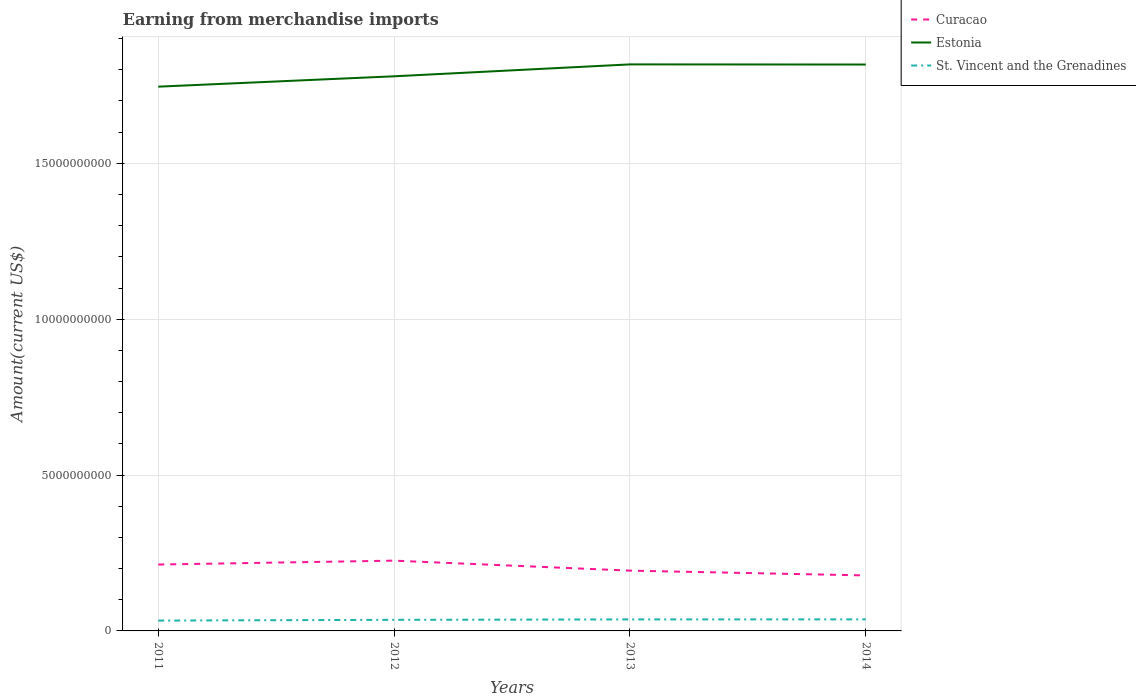Is the number of lines equal to the number of legend labels?
Your answer should be very brief. Yes. Across all years, what is the maximum amount earned from merchandise imports in Estonia?
Keep it short and to the point. 1.75e+1. In which year was the amount earned from merchandise imports in Curacao maximum?
Provide a short and direct response. 2014. What is the total amount earned from merchandise imports in Estonia in the graph?
Make the answer very short. -3.78e+08. What is the difference between the highest and the second highest amount earned from merchandise imports in Estonia?
Provide a short and direct response. 7.15e+08. How many lines are there?
Make the answer very short. 3. What is the difference between two consecutive major ticks on the Y-axis?
Make the answer very short. 5.00e+09. Are the values on the major ticks of Y-axis written in scientific E-notation?
Your response must be concise. No. Where does the legend appear in the graph?
Provide a short and direct response. Top right. What is the title of the graph?
Ensure brevity in your answer.  Earning from merchandise imports. Does "United States" appear as one of the legend labels in the graph?
Provide a short and direct response. No. What is the label or title of the Y-axis?
Offer a terse response. Amount(current US$). What is the Amount(current US$) in Curacao in 2011?
Your answer should be very brief. 2.13e+09. What is the Amount(current US$) in Estonia in 2011?
Give a very brief answer. 1.75e+1. What is the Amount(current US$) in St. Vincent and the Grenadines in 2011?
Give a very brief answer. 3.32e+08. What is the Amount(current US$) of Curacao in 2012?
Your answer should be very brief. 2.25e+09. What is the Amount(current US$) in Estonia in 2012?
Your answer should be compact. 1.78e+1. What is the Amount(current US$) of St. Vincent and the Grenadines in 2012?
Ensure brevity in your answer.  3.56e+08. What is the Amount(current US$) of Curacao in 2013?
Provide a succinct answer. 1.93e+09. What is the Amount(current US$) of Estonia in 2013?
Keep it short and to the point. 1.82e+1. What is the Amount(current US$) in St. Vincent and the Grenadines in 2013?
Your answer should be very brief. 3.69e+08. What is the Amount(current US$) in Curacao in 2014?
Your response must be concise. 1.78e+09. What is the Amount(current US$) in Estonia in 2014?
Provide a succinct answer. 1.82e+1. What is the Amount(current US$) of St. Vincent and the Grenadines in 2014?
Provide a succinct answer. 3.71e+08. Across all years, what is the maximum Amount(current US$) of Curacao?
Your response must be concise. 2.25e+09. Across all years, what is the maximum Amount(current US$) of Estonia?
Your answer should be compact. 1.82e+1. Across all years, what is the maximum Amount(current US$) in St. Vincent and the Grenadines?
Give a very brief answer. 3.71e+08. Across all years, what is the minimum Amount(current US$) in Curacao?
Your response must be concise. 1.78e+09. Across all years, what is the minimum Amount(current US$) in Estonia?
Your response must be concise. 1.75e+1. Across all years, what is the minimum Amount(current US$) of St. Vincent and the Grenadines?
Your answer should be very brief. 3.32e+08. What is the total Amount(current US$) of Curacao in the graph?
Give a very brief answer. 8.10e+09. What is the total Amount(current US$) in Estonia in the graph?
Provide a short and direct response. 7.16e+1. What is the total Amount(current US$) in St. Vincent and the Grenadines in the graph?
Provide a short and direct response. 1.43e+09. What is the difference between the Amount(current US$) in Curacao in 2011 and that in 2012?
Offer a terse response. -1.25e+08. What is the difference between the Amount(current US$) of Estonia in 2011 and that in 2012?
Offer a very short reply. -3.32e+08. What is the difference between the Amount(current US$) in St. Vincent and the Grenadines in 2011 and that in 2012?
Your response must be concise. -2.43e+07. What is the difference between the Amount(current US$) of Curacao in 2011 and that in 2013?
Your response must be concise. 1.96e+08. What is the difference between the Amount(current US$) of Estonia in 2011 and that in 2013?
Your response must be concise. -7.15e+08. What is the difference between the Amount(current US$) in St. Vincent and the Grenadines in 2011 and that in 2013?
Your answer should be very brief. -3.75e+07. What is the difference between the Amount(current US$) in Curacao in 2011 and that in 2014?
Make the answer very short. 3.50e+08. What is the difference between the Amount(current US$) in Estonia in 2011 and that in 2014?
Ensure brevity in your answer.  -7.10e+08. What is the difference between the Amount(current US$) of St. Vincent and the Grenadines in 2011 and that in 2014?
Ensure brevity in your answer.  -3.93e+07. What is the difference between the Amount(current US$) of Curacao in 2012 and that in 2013?
Provide a succinct answer. 3.20e+08. What is the difference between the Amount(current US$) in Estonia in 2012 and that in 2013?
Provide a succinct answer. -3.82e+08. What is the difference between the Amount(current US$) of St. Vincent and the Grenadines in 2012 and that in 2013?
Your answer should be very brief. -1.32e+07. What is the difference between the Amount(current US$) in Curacao in 2012 and that in 2014?
Offer a very short reply. 4.74e+08. What is the difference between the Amount(current US$) in Estonia in 2012 and that in 2014?
Give a very brief answer. -3.78e+08. What is the difference between the Amount(current US$) of St. Vincent and the Grenadines in 2012 and that in 2014?
Your answer should be very brief. -1.50e+07. What is the difference between the Amount(current US$) in Curacao in 2013 and that in 2014?
Your response must be concise. 1.54e+08. What is the difference between the Amount(current US$) in Estonia in 2013 and that in 2014?
Give a very brief answer. 4.62e+06. What is the difference between the Amount(current US$) of St. Vincent and the Grenadines in 2013 and that in 2014?
Provide a succinct answer. -1.76e+06. What is the difference between the Amount(current US$) in Curacao in 2011 and the Amount(current US$) in Estonia in 2012?
Make the answer very short. -1.57e+1. What is the difference between the Amount(current US$) in Curacao in 2011 and the Amount(current US$) in St. Vincent and the Grenadines in 2012?
Make the answer very short. 1.77e+09. What is the difference between the Amount(current US$) of Estonia in 2011 and the Amount(current US$) of St. Vincent and the Grenadines in 2012?
Make the answer very short. 1.71e+1. What is the difference between the Amount(current US$) in Curacao in 2011 and the Amount(current US$) in Estonia in 2013?
Your answer should be compact. -1.60e+1. What is the difference between the Amount(current US$) of Curacao in 2011 and the Amount(current US$) of St. Vincent and the Grenadines in 2013?
Offer a very short reply. 1.76e+09. What is the difference between the Amount(current US$) in Estonia in 2011 and the Amount(current US$) in St. Vincent and the Grenadines in 2013?
Ensure brevity in your answer.  1.71e+1. What is the difference between the Amount(current US$) in Curacao in 2011 and the Amount(current US$) in Estonia in 2014?
Make the answer very short. -1.60e+1. What is the difference between the Amount(current US$) in Curacao in 2011 and the Amount(current US$) in St. Vincent and the Grenadines in 2014?
Keep it short and to the point. 1.76e+09. What is the difference between the Amount(current US$) in Estonia in 2011 and the Amount(current US$) in St. Vincent and the Grenadines in 2014?
Provide a succinct answer. 1.71e+1. What is the difference between the Amount(current US$) of Curacao in 2012 and the Amount(current US$) of Estonia in 2013?
Your answer should be very brief. -1.59e+1. What is the difference between the Amount(current US$) of Curacao in 2012 and the Amount(current US$) of St. Vincent and the Grenadines in 2013?
Provide a short and direct response. 1.89e+09. What is the difference between the Amount(current US$) in Estonia in 2012 and the Amount(current US$) in St. Vincent and the Grenadines in 2013?
Offer a terse response. 1.74e+1. What is the difference between the Amount(current US$) in Curacao in 2012 and the Amount(current US$) in Estonia in 2014?
Your answer should be very brief. -1.59e+1. What is the difference between the Amount(current US$) of Curacao in 2012 and the Amount(current US$) of St. Vincent and the Grenadines in 2014?
Provide a short and direct response. 1.88e+09. What is the difference between the Amount(current US$) of Estonia in 2012 and the Amount(current US$) of St. Vincent and the Grenadines in 2014?
Provide a succinct answer. 1.74e+1. What is the difference between the Amount(current US$) of Curacao in 2013 and the Amount(current US$) of Estonia in 2014?
Provide a short and direct response. -1.62e+1. What is the difference between the Amount(current US$) in Curacao in 2013 and the Amount(current US$) in St. Vincent and the Grenadines in 2014?
Ensure brevity in your answer.  1.56e+09. What is the difference between the Amount(current US$) in Estonia in 2013 and the Amount(current US$) in St. Vincent and the Grenadines in 2014?
Offer a very short reply. 1.78e+1. What is the average Amount(current US$) of Curacao per year?
Your response must be concise. 2.02e+09. What is the average Amount(current US$) of Estonia per year?
Your answer should be compact. 1.79e+1. What is the average Amount(current US$) of St. Vincent and the Grenadines per year?
Keep it short and to the point. 3.57e+08. In the year 2011, what is the difference between the Amount(current US$) of Curacao and Amount(current US$) of Estonia?
Provide a short and direct response. -1.53e+1. In the year 2011, what is the difference between the Amount(current US$) of Curacao and Amount(current US$) of St. Vincent and the Grenadines?
Offer a very short reply. 1.80e+09. In the year 2011, what is the difference between the Amount(current US$) of Estonia and Amount(current US$) of St. Vincent and the Grenadines?
Provide a short and direct response. 1.71e+1. In the year 2012, what is the difference between the Amount(current US$) of Curacao and Amount(current US$) of Estonia?
Offer a terse response. -1.55e+1. In the year 2012, what is the difference between the Amount(current US$) of Curacao and Amount(current US$) of St. Vincent and the Grenadines?
Offer a terse response. 1.90e+09. In the year 2012, what is the difference between the Amount(current US$) in Estonia and Amount(current US$) in St. Vincent and the Grenadines?
Offer a very short reply. 1.74e+1. In the year 2013, what is the difference between the Amount(current US$) of Curacao and Amount(current US$) of Estonia?
Provide a succinct answer. -1.62e+1. In the year 2013, what is the difference between the Amount(current US$) in Curacao and Amount(current US$) in St. Vincent and the Grenadines?
Offer a terse response. 1.56e+09. In the year 2013, what is the difference between the Amount(current US$) of Estonia and Amount(current US$) of St. Vincent and the Grenadines?
Keep it short and to the point. 1.78e+1. In the year 2014, what is the difference between the Amount(current US$) of Curacao and Amount(current US$) of Estonia?
Provide a succinct answer. -1.64e+1. In the year 2014, what is the difference between the Amount(current US$) in Curacao and Amount(current US$) in St. Vincent and the Grenadines?
Provide a succinct answer. 1.41e+09. In the year 2014, what is the difference between the Amount(current US$) in Estonia and Amount(current US$) in St. Vincent and the Grenadines?
Provide a succinct answer. 1.78e+1. What is the ratio of the Amount(current US$) in Curacao in 2011 to that in 2012?
Keep it short and to the point. 0.94. What is the ratio of the Amount(current US$) of Estonia in 2011 to that in 2012?
Keep it short and to the point. 0.98. What is the ratio of the Amount(current US$) of St. Vincent and the Grenadines in 2011 to that in 2012?
Ensure brevity in your answer.  0.93. What is the ratio of the Amount(current US$) of Curacao in 2011 to that in 2013?
Provide a succinct answer. 1.1. What is the ratio of the Amount(current US$) in Estonia in 2011 to that in 2013?
Provide a succinct answer. 0.96. What is the ratio of the Amount(current US$) in St. Vincent and the Grenadines in 2011 to that in 2013?
Offer a terse response. 0.9. What is the ratio of the Amount(current US$) of Curacao in 2011 to that in 2014?
Your answer should be compact. 1.2. What is the ratio of the Amount(current US$) of Estonia in 2011 to that in 2014?
Keep it short and to the point. 0.96. What is the ratio of the Amount(current US$) in St. Vincent and the Grenadines in 2011 to that in 2014?
Your answer should be very brief. 0.89. What is the ratio of the Amount(current US$) of Curacao in 2012 to that in 2013?
Your response must be concise. 1.17. What is the ratio of the Amount(current US$) of Curacao in 2012 to that in 2014?
Your response must be concise. 1.27. What is the ratio of the Amount(current US$) of Estonia in 2012 to that in 2014?
Keep it short and to the point. 0.98. What is the ratio of the Amount(current US$) of St. Vincent and the Grenadines in 2012 to that in 2014?
Your response must be concise. 0.96. What is the ratio of the Amount(current US$) of Curacao in 2013 to that in 2014?
Your answer should be very brief. 1.09. What is the difference between the highest and the second highest Amount(current US$) of Curacao?
Your answer should be very brief. 1.25e+08. What is the difference between the highest and the second highest Amount(current US$) of Estonia?
Provide a succinct answer. 4.62e+06. What is the difference between the highest and the second highest Amount(current US$) in St. Vincent and the Grenadines?
Your answer should be compact. 1.76e+06. What is the difference between the highest and the lowest Amount(current US$) in Curacao?
Offer a very short reply. 4.74e+08. What is the difference between the highest and the lowest Amount(current US$) of Estonia?
Your response must be concise. 7.15e+08. What is the difference between the highest and the lowest Amount(current US$) in St. Vincent and the Grenadines?
Your response must be concise. 3.93e+07. 